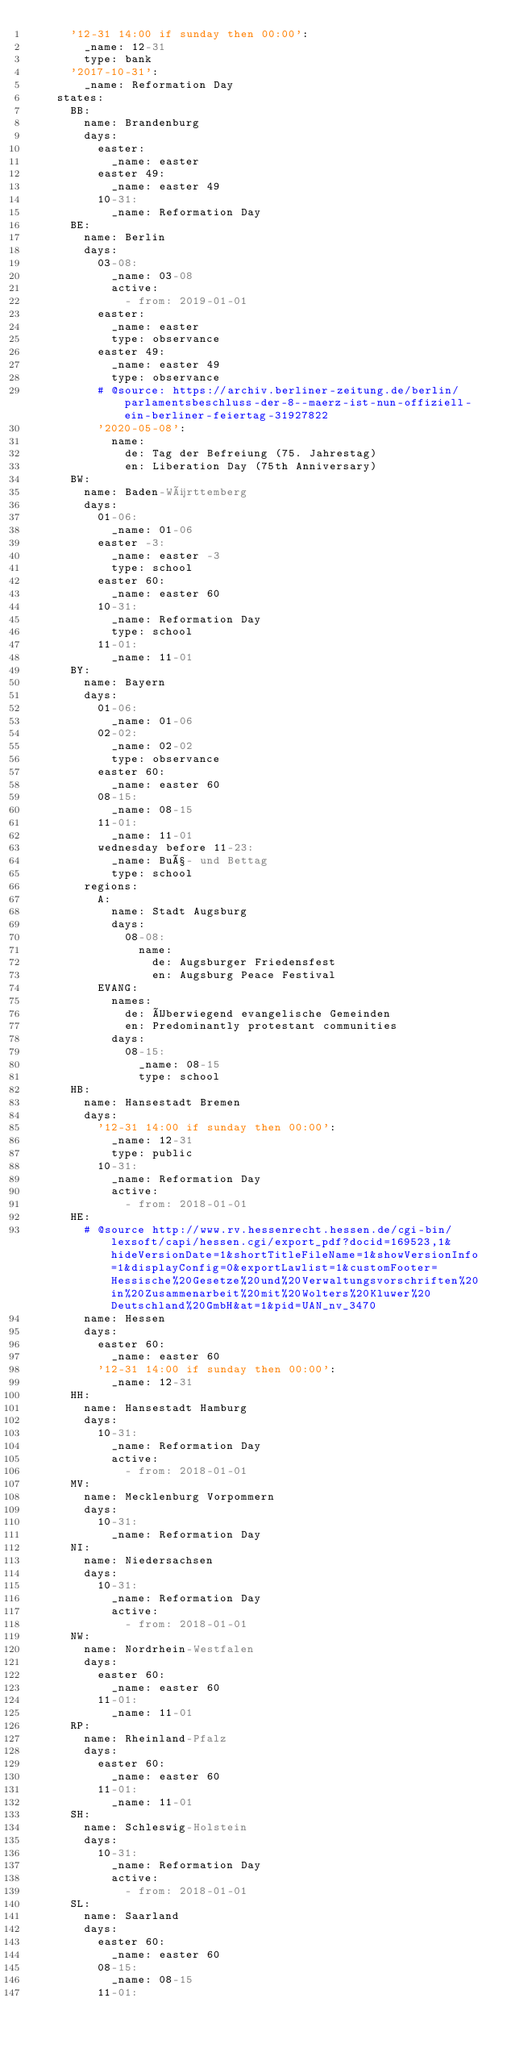<code> <loc_0><loc_0><loc_500><loc_500><_YAML_>      '12-31 14:00 if sunday then 00:00':
        _name: 12-31
        type: bank
      '2017-10-31':
        _name: Reformation Day
    states:
      BB:
        name: Brandenburg
        days:
          easter:
            _name: easter
          easter 49:
            _name: easter 49
          10-31:
            _name: Reformation Day
      BE:
        name: Berlin
        days:
          03-08:
            _name: 03-08
            active:
              - from: 2019-01-01
          easter:
            _name: easter
            type: observance
          easter 49:
            _name: easter 49
            type: observance
          # @source: https://archiv.berliner-zeitung.de/berlin/parlamentsbeschluss-der-8--maerz-ist-nun-offiziell-ein-berliner-feiertag-31927822
          '2020-05-08':
            name:
              de: Tag der Befreiung (75. Jahrestag)
              en: Liberation Day (75th Anniversary)
      BW:
        name: Baden-Württemberg
        days:
          01-06:
            _name: 01-06
          easter -3:
            _name: easter -3
            type: school
          easter 60:
            _name: easter 60
          10-31:
            _name: Reformation Day
            type: school
          11-01:
            _name: 11-01
      BY:
        name: Bayern
        days:
          01-06:
            _name: 01-06
          02-02:
            _name: 02-02
            type: observance
          easter 60:
            _name: easter 60
          08-15:
            _name: 08-15
          11-01:
            _name: 11-01
          wednesday before 11-23:
            _name: Buß- und Bettag
            type: school
        regions:
          A:
            name: Stadt Augsburg
            days:
              08-08:
                name:
                  de: Augsburger Friedensfest
                  en: Augsburg Peace Festival
          EVANG:
            names:
              de: Überwiegend evangelische Gemeinden
              en: Predominantly protestant communities
            days:
              08-15:
                _name: 08-15
                type: school
      HB:
        name: Hansestadt Bremen
        days:
          '12-31 14:00 if sunday then 00:00':
            _name: 12-31
            type: public
          10-31:
            _name: Reformation Day
            active:
              - from: 2018-01-01
      HE:
        # @source http://www.rv.hessenrecht.hessen.de/cgi-bin/lexsoft/capi/hessen.cgi/export_pdf?docid=169523,1&hideVersionDate=1&shortTitleFileName=1&showVersionInfo=1&displayConfig=0&exportLawlist=1&customFooter=Hessische%20Gesetze%20und%20Verwaltungsvorschriften%20in%20Zusammenarbeit%20mit%20Wolters%20Kluwer%20Deutschland%20GmbH&at=1&pid=UAN_nv_3470
        name: Hessen
        days:
          easter 60:
            _name: easter 60
          '12-31 14:00 if sunday then 00:00':
            _name: 12-31
      HH:
        name: Hansestadt Hamburg
        days:
          10-31:
            _name: Reformation Day
            active:
              - from: 2018-01-01
      MV:
        name: Mecklenburg Vorpommern
        days:
          10-31:
            _name: Reformation Day
      NI:
        name: Niedersachsen
        days:
          10-31:
            _name: Reformation Day
            active:
              - from: 2018-01-01
      NW:
        name: Nordrhein-Westfalen
        days:
          easter 60:
            _name: easter 60
          11-01:
            _name: 11-01
      RP:
        name: Rheinland-Pfalz
        days:
          easter 60:
            _name: easter 60
          11-01:
            _name: 11-01
      SH:
        name: Schleswig-Holstein
        days:
          10-31:
            _name: Reformation Day
            active:
              - from: 2018-01-01
      SL:
        name: Saarland
        days:
          easter 60:
            _name: easter 60
          08-15:
            _name: 08-15
          11-01:</code> 